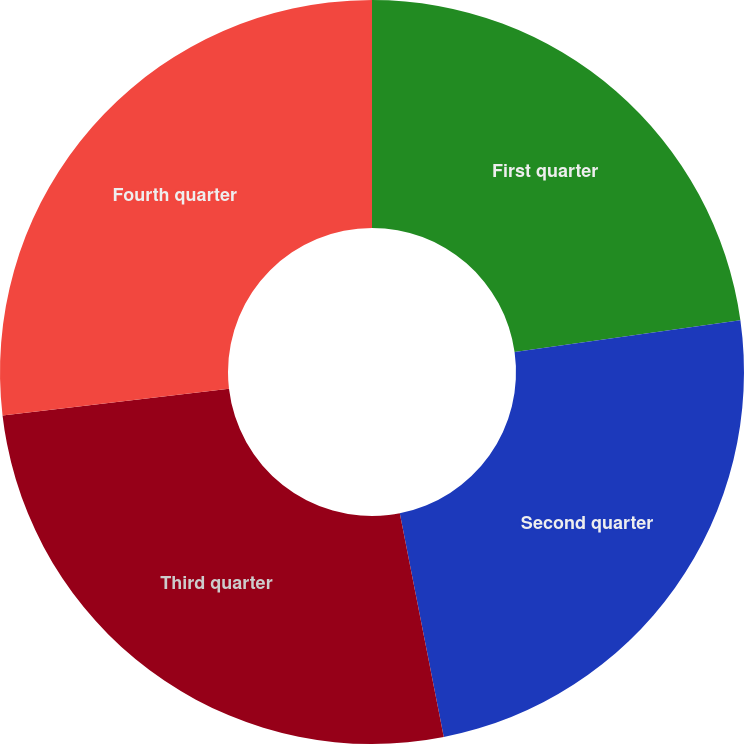Convert chart. <chart><loc_0><loc_0><loc_500><loc_500><pie_chart><fcel>First quarter<fcel>Second quarter<fcel>Third quarter<fcel>Fourth quarter<nl><fcel>22.78%<fcel>24.13%<fcel>26.23%<fcel>26.86%<nl></chart> 